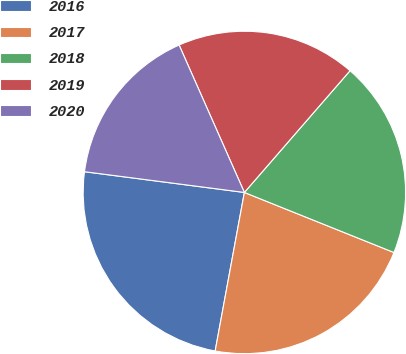<chart> <loc_0><loc_0><loc_500><loc_500><pie_chart><fcel>2016<fcel>2017<fcel>2018<fcel>2019<fcel>2020<nl><fcel>24.15%<fcel>21.82%<fcel>19.7%<fcel>18.01%<fcel>16.31%<nl></chart> 